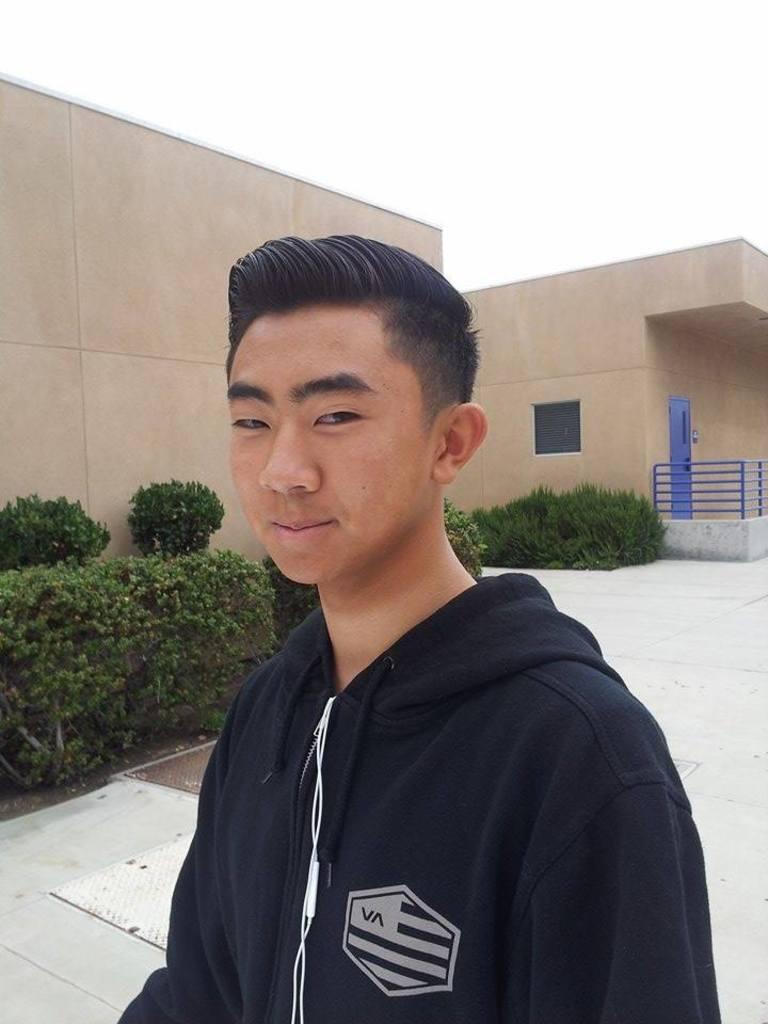Please provide a concise description of this image. In this image I can see a person wearing a black color jacket , in the middle I can see houses and in front of houses I can see bushes and at the top I can see the sky. 